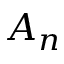Convert formula to latex. <formula><loc_0><loc_0><loc_500><loc_500>A _ { n }</formula> 